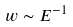<formula> <loc_0><loc_0><loc_500><loc_500>w \sim E ^ { - 1 }</formula> 